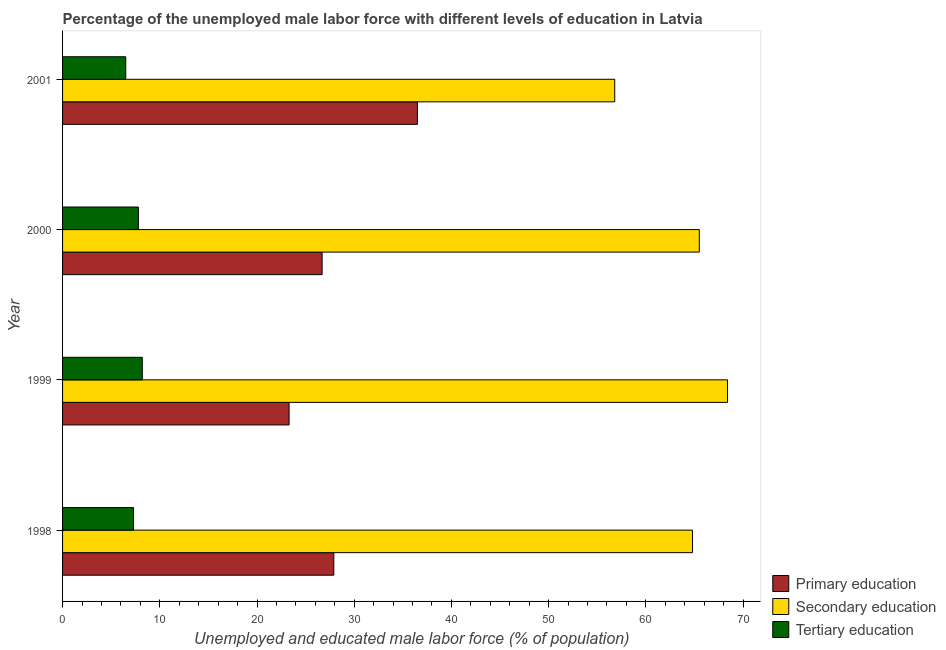How many different coloured bars are there?
Make the answer very short. 3. How many groups of bars are there?
Offer a terse response. 4. Are the number of bars per tick equal to the number of legend labels?
Provide a short and direct response. Yes. How many bars are there on the 1st tick from the bottom?
Offer a terse response. 3. What is the percentage of male labor force who received tertiary education in 2000?
Make the answer very short. 7.8. Across all years, what is the maximum percentage of male labor force who received primary education?
Offer a very short reply. 36.5. What is the total percentage of male labor force who received secondary education in the graph?
Your answer should be compact. 255.5. What is the difference between the percentage of male labor force who received tertiary education in 1998 and the percentage of male labor force who received secondary education in 2000?
Give a very brief answer. -58.2. What is the average percentage of male labor force who received secondary education per year?
Offer a terse response. 63.88. In how many years, is the percentage of male labor force who received primary education greater than 22 %?
Ensure brevity in your answer.  4. What is the ratio of the percentage of male labor force who received tertiary education in 1998 to that in 2000?
Your answer should be very brief. 0.94. Is the percentage of male labor force who received primary education in 1999 less than that in 2001?
Ensure brevity in your answer.  Yes. What is the difference between the highest and the second highest percentage of male labor force who received primary education?
Give a very brief answer. 8.6. What is the difference between the highest and the lowest percentage of male labor force who received secondary education?
Give a very brief answer. 11.6. Is the sum of the percentage of male labor force who received primary education in 1998 and 2001 greater than the maximum percentage of male labor force who received secondary education across all years?
Ensure brevity in your answer.  No. What does the 1st bar from the top in 1998 represents?
Make the answer very short. Tertiary education. What does the 2nd bar from the bottom in 2001 represents?
Give a very brief answer. Secondary education. Is it the case that in every year, the sum of the percentage of male labor force who received primary education and percentage of male labor force who received secondary education is greater than the percentage of male labor force who received tertiary education?
Offer a very short reply. Yes. Are the values on the major ticks of X-axis written in scientific E-notation?
Provide a succinct answer. No. Does the graph contain grids?
Give a very brief answer. No. Where does the legend appear in the graph?
Ensure brevity in your answer.  Bottom right. How are the legend labels stacked?
Provide a succinct answer. Vertical. What is the title of the graph?
Make the answer very short. Percentage of the unemployed male labor force with different levels of education in Latvia. Does "Czech Republic" appear as one of the legend labels in the graph?
Make the answer very short. No. What is the label or title of the X-axis?
Keep it short and to the point. Unemployed and educated male labor force (% of population). What is the Unemployed and educated male labor force (% of population) in Primary education in 1998?
Make the answer very short. 27.9. What is the Unemployed and educated male labor force (% of population) in Secondary education in 1998?
Provide a short and direct response. 64.8. What is the Unemployed and educated male labor force (% of population) in Tertiary education in 1998?
Your response must be concise. 7.3. What is the Unemployed and educated male labor force (% of population) in Primary education in 1999?
Offer a very short reply. 23.3. What is the Unemployed and educated male labor force (% of population) in Secondary education in 1999?
Your answer should be compact. 68.4. What is the Unemployed and educated male labor force (% of population) in Tertiary education in 1999?
Your response must be concise. 8.2. What is the Unemployed and educated male labor force (% of population) of Primary education in 2000?
Offer a terse response. 26.7. What is the Unemployed and educated male labor force (% of population) of Secondary education in 2000?
Make the answer very short. 65.5. What is the Unemployed and educated male labor force (% of population) in Tertiary education in 2000?
Ensure brevity in your answer.  7.8. What is the Unemployed and educated male labor force (% of population) of Primary education in 2001?
Your response must be concise. 36.5. What is the Unemployed and educated male labor force (% of population) of Secondary education in 2001?
Offer a terse response. 56.8. Across all years, what is the maximum Unemployed and educated male labor force (% of population) in Primary education?
Your answer should be compact. 36.5. Across all years, what is the maximum Unemployed and educated male labor force (% of population) in Secondary education?
Provide a succinct answer. 68.4. Across all years, what is the maximum Unemployed and educated male labor force (% of population) in Tertiary education?
Offer a terse response. 8.2. Across all years, what is the minimum Unemployed and educated male labor force (% of population) of Primary education?
Provide a succinct answer. 23.3. Across all years, what is the minimum Unemployed and educated male labor force (% of population) in Secondary education?
Your answer should be compact. 56.8. Across all years, what is the minimum Unemployed and educated male labor force (% of population) of Tertiary education?
Ensure brevity in your answer.  6.5. What is the total Unemployed and educated male labor force (% of population) in Primary education in the graph?
Offer a terse response. 114.4. What is the total Unemployed and educated male labor force (% of population) of Secondary education in the graph?
Provide a short and direct response. 255.5. What is the total Unemployed and educated male labor force (% of population) in Tertiary education in the graph?
Your response must be concise. 29.8. What is the difference between the Unemployed and educated male labor force (% of population) in Tertiary education in 1998 and that in 1999?
Provide a short and direct response. -0.9. What is the difference between the Unemployed and educated male labor force (% of population) of Primary education in 1998 and that in 2000?
Offer a terse response. 1.2. What is the difference between the Unemployed and educated male labor force (% of population) in Tertiary education in 1998 and that in 2000?
Ensure brevity in your answer.  -0.5. What is the difference between the Unemployed and educated male labor force (% of population) of Primary education in 1998 and that in 2001?
Your response must be concise. -8.6. What is the difference between the Unemployed and educated male labor force (% of population) of Secondary education in 1999 and that in 2000?
Provide a succinct answer. 2.9. What is the difference between the Unemployed and educated male labor force (% of population) of Primary education in 1999 and that in 2001?
Offer a very short reply. -13.2. What is the difference between the Unemployed and educated male labor force (% of population) of Primary education in 1998 and the Unemployed and educated male labor force (% of population) of Secondary education in 1999?
Make the answer very short. -40.5. What is the difference between the Unemployed and educated male labor force (% of population) in Primary education in 1998 and the Unemployed and educated male labor force (% of population) in Tertiary education in 1999?
Offer a very short reply. 19.7. What is the difference between the Unemployed and educated male labor force (% of population) in Secondary education in 1998 and the Unemployed and educated male labor force (% of population) in Tertiary education in 1999?
Make the answer very short. 56.6. What is the difference between the Unemployed and educated male labor force (% of population) in Primary education in 1998 and the Unemployed and educated male labor force (% of population) in Secondary education in 2000?
Your answer should be very brief. -37.6. What is the difference between the Unemployed and educated male labor force (% of population) of Primary education in 1998 and the Unemployed and educated male labor force (% of population) of Tertiary education in 2000?
Make the answer very short. 20.1. What is the difference between the Unemployed and educated male labor force (% of population) in Primary education in 1998 and the Unemployed and educated male labor force (% of population) in Secondary education in 2001?
Offer a very short reply. -28.9. What is the difference between the Unemployed and educated male labor force (% of population) of Primary education in 1998 and the Unemployed and educated male labor force (% of population) of Tertiary education in 2001?
Offer a very short reply. 21.4. What is the difference between the Unemployed and educated male labor force (% of population) in Secondary education in 1998 and the Unemployed and educated male labor force (% of population) in Tertiary education in 2001?
Your response must be concise. 58.3. What is the difference between the Unemployed and educated male labor force (% of population) in Primary education in 1999 and the Unemployed and educated male labor force (% of population) in Secondary education in 2000?
Your response must be concise. -42.2. What is the difference between the Unemployed and educated male labor force (% of population) of Primary education in 1999 and the Unemployed and educated male labor force (% of population) of Tertiary education in 2000?
Your response must be concise. 15.5. What is the difference between the Unemployed and educated male labor force (% of population) in Secondary education in 1999 and the Unemployed and educated male labor force (% of population) in Tertiary education in 2000?
Ensure brevity in your answer.  60.6. What is the difference between the Unemployed and educated male labor force (% of population) in Primary education in 1999 and the Unemployed and educated male labor force (% of population) in Secondary education in 2001?
Offer a very short reply. -33.5. What is the difference between the Unemployed and educated male labor force (% of population) of Secondary education in 1999 and the Unemployed and educated male labor force (% of population) of Tertiary education in 2001?
Make the answer very short. 61.9. What is the difference between the Unemployed and educated male labor force (% of population) of Primary education in 2000 and the Unemployed and educated male labor force (% of population) of Secondary education in 2001?
Make the answer very short. -30.1. What is the difference between the Unemployed and educated male labor force (% of population) in Primary education in 2000 and the Unemployed and educated male labor force (% of population) in Tertiary education in 2001?
Offer a terse response. 20.2. What is the difference between the Unemployed and educated male labor force (% of population) of Secondary education in 2000 and the Unemployed and educated male labor force (% of population) of Tertiary education in 2001?
Offer a terse response. 59. What is the average Unemployed and educated male labor force (% of population) in Primary education per year?
Your answer should be very brief. 28.6. What is the average Unemployed and educated male labor force (% of population) of Secondary education per year?
Ensure brevity in your answer.  63.88. What is the average Unemployed and educated male labor force (% of population) in Tertiary education per year?
Your response must be concise. 7.45. In the year 1998, what is the difference between the Unemployed and educated male labor force (% of population) in Primary education and Unemployed and educated male labor force (% of population) in Secondary education?
Your response must be concise. -36.9. In the year 1998, what is the difference between the Unemployed and educated male labor force (% of population) of Primary education and Unemployed and educated male labor force (% of population) of Tertiary education?
Provide a succinct answer. 20.6. In the year 1998, what is the difference between the Unemployed and educated male labor force (% of population) in Secondary education and Unemployed and educated male labor force (% of population) in Tertiary education?
Provide a succinct answer. 57.5. In the year 1999, what is the difference between the Unemployed and educated male labor force (% of population) in Primary education and Unemployed and educated male labor force (% of population) in Secondary education?
Your response must be concise. -45.1. In the year 1999, what is the difference between the Unemployed and educated male labor force (% of population) of Primary education and Unemployed and educated male labor force (% of population) of Tertiary education?
Your answer should be compact. 15.1. In the year 1999, what is the difference between the Unemployed and educated male labor force (% of population) in Secondary education and Unemployed and educated male labor force (% of population) in Tertiary education?
Offer a very short reply. 60.2. In the year 2000, what is the difference between the Unemployed and educated male labor force (% of population) in Primary education and Unemployed and educated male labor force (% of population) in Secondary education?
Offer a very short reply. -38.8. In the year 2000, what is the difference between the Unemployed and educated male labor force (% of population) of Primary education and Unemployed and educated male labor force (% of population) of Tertiary education?
Ensure brevity in your answer.  18.9. In the year 2000, what is the difference between the Unemployed and educated male labor force (% of population) of Secondary education and Unemployed and educated male labor force (% of population) of Tertiary education?
Make the answer very short. 57.7. In the year 2001, what is the difference between the Unemployed and educated male labor force (% of population) in Primary education and Unemployed and educated male labor force (% of population) in Secondary education?
Your answer should be compact. -20.3. In the year 2001, what is the difference between the Unemployed and educated male labor force (% of population) of Primary education and Unemployed and educated male labor force (% of population) of Tertiary education?
Offer a terse response. 30. In the year 2001, what is the difference between the Unemployed and educated male labor force (% of population) of Secondary education and Unemployed and educated male labor force (% of population) of Tertiary education?
Make the answer very short. 50.3. What is the ratio of the Unemployed and educated male labor force (% of population) in Primary education in 1998 to that in 1999?
Provide a succinct answer. 1.2. What is the ratio of the Unemployed and educated male labor force (% of population) in Tertiary education in 1998 to that in 1999?
Offer a very short reply. 0.89. What is the ratio of the Unemployed and educated male labor force (% of population) in Primary education in 1998 to that in 2000?
Your response must be concise. 1.04. What is the ratio of the Unemployed and educated male labor force (% of population) in Secondary education in 1998 to that in 2000?
Your response must be concise. 0.99. What is the ratio of the Unemployed and educated male labor force (% of population) of Tertiary education in 1998 to that in 2000?
Offer a very short reply. 0.94. What is the ratio of the Unemployed and educated male labor force (% of population) in Primary education in 1998 to that in 2001?
Make the answer very short. 0.76. What is the ratio of the Unemployed and educated male labor force (% of population) in Secondary education in 1998 to that in 2001?
Offer a terse response. 1.14. What is the ratio of the Unemployed and educated male labor force (% of population) in Tertiary education in 1998 to that in 2001?
Offer a very short reply. 1.12. What is the ratio of the Unemployed and educated male labor force (% of population) in Primary education in 1999 to that in 2000?
Provide a succinct answer. 0.87. What is the ratio of the Unemployed and educated male labor force (% of population) of Secondary education in 1999 to that in 2000?
Your answer should be very brief. 1.04. What is the ratio of the Unemployed and educated male labor force (% of population) in Tertiary education in 1999 to that in 2000?
Give a very brief answer. 1.05. What is the ratio of the Unemployed and educated male labor force (% of population) in Primary education in 1999 to that in 2001?
Make the answer very short. 0.64. What is the ratio of the Unemployed and educated male labor force (% of population) of Secondary education in 1999 to that in 2001?
Your answer should be compact. 1.2. What is the ratio of the Unemployed and educated male labor force (% of population) in Tertiary education in 1999 to that in 2001?
Make the answer very short. 1.26. What is the ratio of the Unemployed and educated male labor force (% of population) of Primary education in 2000 to that in 2001?
Your answer should be compact. 0.73. What is the ratio of the Unemployed and educated male labor force (% of population) in Secondary education in 2000 to that in 2001?
Keep it short and to the point. 1.15. What is the difference between the highest and the second highest Unemployed and educated male labor force (% of population) of Primary education?
Your response must be concise. 8.6. What is the difference between the highest and the second highest Unemployed and educated male labor force (% of population) of Tertiary education?
Your response must be concise. 0.4. What is the difference between the highest and the lowest Unemployed and educated male labor force (% of population) in Primary education?
Provide a succinct answer. 13.2. What is the difference between the highest and the lowest Unemployed and educated male labor force (% of population) in Tertiary education?
Your answer should be compact. 1.7. 